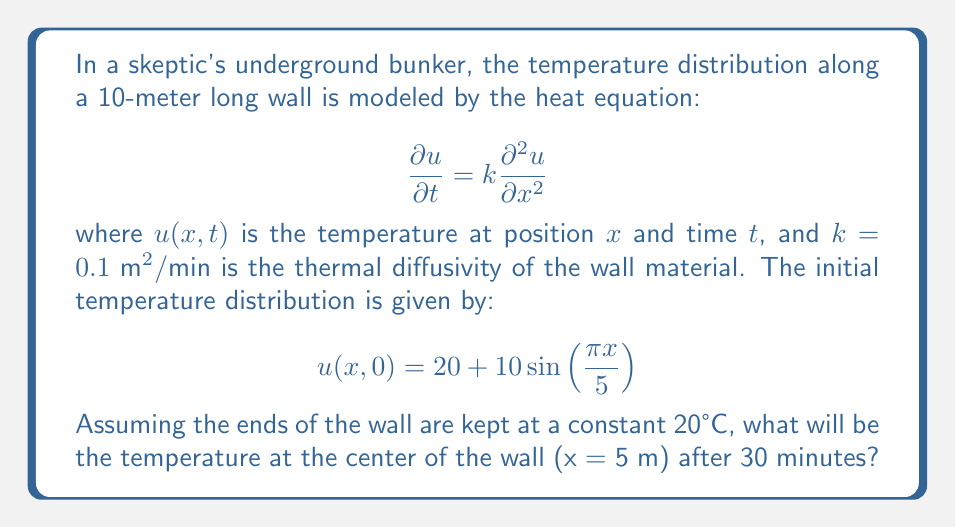What is the answer to this math problem? To solve this problem, we need to use the separation of variables method for the heat equation with given initial and boundary conditions.

1) The general solution for the heat equation with these boundary conditions is:

   $$u(x,t) = 20 + \sum_{n=1}^{\infty} B_n \sin(\frac{n\pi x}{10})e^{-k(\frac{n\pi}{10})^2t}$$

2) We need to find $B_n$ that satisfies the initial condition:

   $$20 + 10\sin(\frac{\pi x}{5}) = 20 + \sum_{n=1}^{\infty} B_n \sin(\frac{n\pi x}{10})$$

3) Comparing the terms, we see that $B_n = 0$ for all $n$ except when $n = 2$, where $B_2 = 10$.

4) Therefore, our solution simplifies to:

   $$u(x,t) = 20 + 10\sin(\frac{\pi x}{5})e^{-k(\frac{\pi}{5})^2t}$$

5) At the center of the wall, $x = 5$ m. After 30 minutes, $t = 30$. Substituting these values:

   $$u(5,30) = 20 + 10\sin(\frac{\pi \cdot 5}{5})e^{-0.1(\frac{\pi}{5})^2 \cdot 30}$$

6) Simplify:
   $$u(5,30) = 20 + 10\sin(\pi)e^{-0.1(\frac{\pi}{5})^2 \cdot 30}$$
   $$u(5,30) = 20 + 0 \cdot e^{-0.1(\frac{\pi}{5})^2 \cdot 30}$$
   $$u(5,30) = 20$$

Therefore, the temperature at the center of the wall after 30 minutes will be 20°C.
Answer: 20°C 